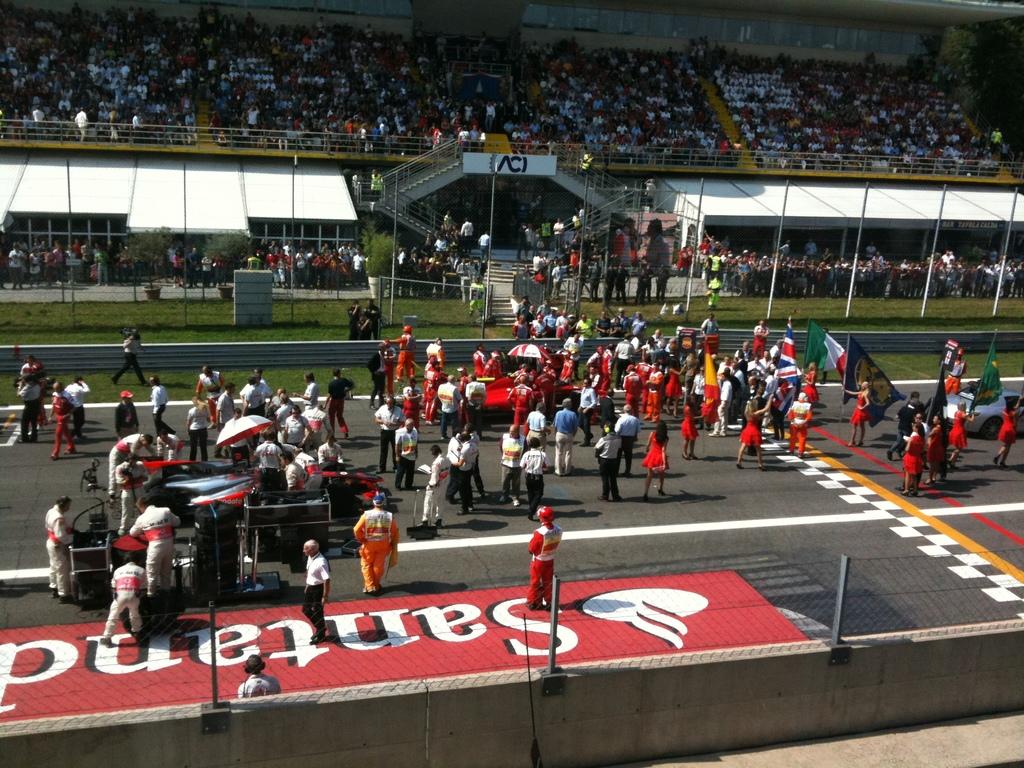What company is the red banner showing?
Provide a succinct answer. Santand. 